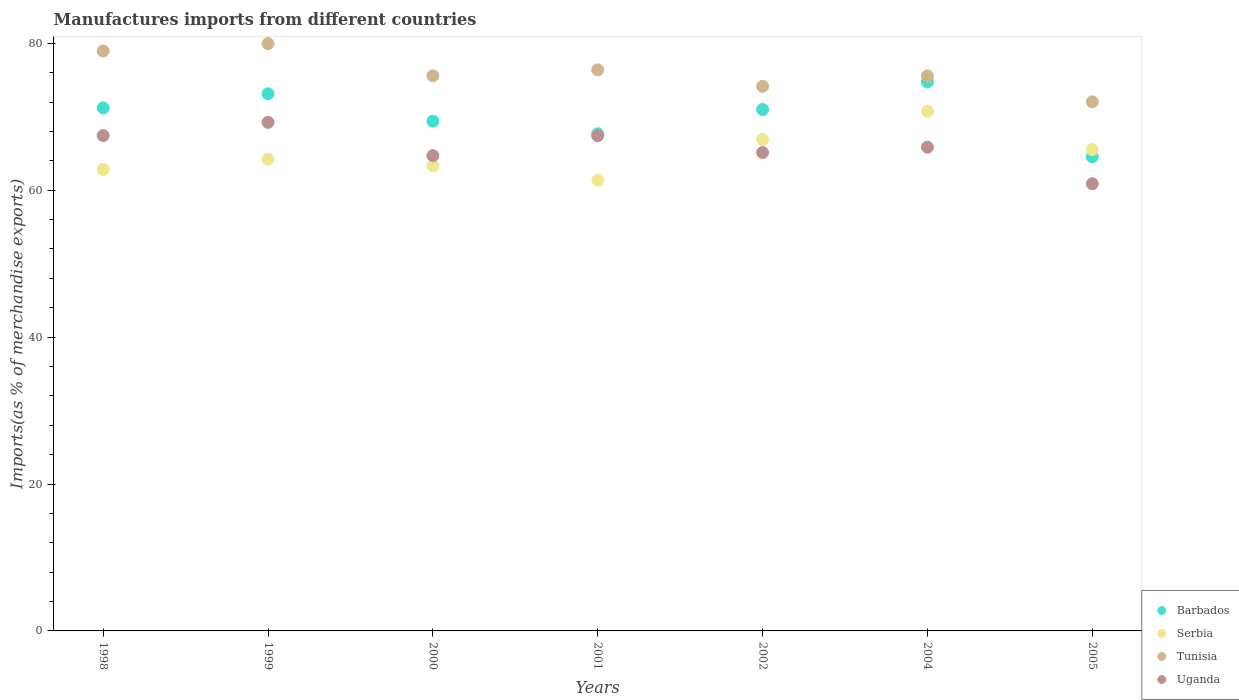Is the number of dotlines equal to the number of legend labels?
Offer a terse response. Yes. What is the percentage of imports to different countries in Serbia in 2005?
Offer a terse response. 65.52. Across all years, what is the maximum percentage of imports to different countries in Barbados?
Provide a short and direct response. 74.74. Across all years, what is the minimum percentage of imports to different countries in Uganda?
Your response must be concise. 60.88. What is the total percentage of imports to different countries in Uganda in the graph?
Provide a succinct answer. 460.66. What is the difference between the percentage of imports to different countries in Serbia in 1998 and that in 2002?
Make the answer very short. -4.08. What is the difference between the percentage of imports to different countries in Barbados in 1999 and the percentage of imports to different countries in Serbia in 2000?
Your answer should be compact. 9.79. What is the average percentage of imports to different countries in Tunisia per year?
Your answer should be very brief. 76.09. In the year 2002, what is the difference between the percentage of imports to different countries in Barbados and percentage of imports to different countries in Tunisia?
Make the answer very short. -3.16. In how many years, is the percentage of imports to different countries in Serbia greater than 24 %?
Provide a succinct answer. 7. What is the ratio of the percentage of imports to different countries in Tunisia in 1998 to that in 2002?
Make the answer very short. 1.06. Is the difference between the percentage of imports to different countries in Barbados in 2001 and 2004 greater than the difference between the percentage of imports to different countries in Tunisia in 2001 and 2004?
Offer a very short reply. No. What is the difference between the highest and the second highest percentage of imports to different countries in Barbados?
Make the answer very short. 1.61. What is the difference between the highest and the lowest percentage of imports to different countries in Uganda?
Your answer should be very brief. 8.36. Is the sum of the percentage of imports to different countries in Barbados in 1999 and 2002 greater than the maximum percentage of imports to different countries in Tunisia across all years?
Make the answer very short. Yes. Is it the case that in every year, the sum of the percentage of imports to different countries in Tunisia and percentage of imports to different countries in Serbia  is greater than the sum of percentage of imports to different countries in Barbados and percentage of imports to different countries in Uganda?
Your answer should be very brief. No. Does the percentage of imports to different countries in Barbados monotonically increase over the years?
Your response must be concise. No. How many dotlines are there?
Offer a very short reply. 4. What is the difference between two consecutive major ticks on the Y-axis?
Give a very brief answer. 20. Are the values on the major ticks of Y-axis written in scientific E-notation?
Your answer should be compact. No. How many legend labels are there?
Make the answer very short. 4. What is the title of the graph?
Your answer should be compact. Manufactures imports from different countries. What is the label or title of the Y-axis?
Your response must be concise. Imports(as % of merchandise exports). What is the Imports(as % of merchandise exports) of Barbados in 1998?
Make the answer very short. 71.2. What is the Imports(as % of merchandise exports) of Serbia in 1998?
Your response must be concise. 62.83. What is the Imports(as % of merchandise exports) in Tunisia in 1998?
Provide a succinct answer. 78.95. What is the Imports(as % of merchandise exports) of Uganda in 1998?
Provide a succinct answer. 67.44. What is the Imports(as % of merchandise exports) of Barbados in 1999?
Offer a terse response. 73.13. What is the Imports(as % of merchandise exports) of Serbia in 1999?
Keep it short and to the point. 64.21. What is the Imports(as % of merchandise exports) of Tunisia in 1999?
Offer a terse response. 79.96. What is the Imports(as % of merchandise exports) in Uganda in 1999?
Make the answer very short. 69.24. What is the Imports(as % of merchandise exports) of Barbados in 2000?
Offer a very short reply. 69.4. What is the Imports(as % of merchandise exports) in Serbia in 2000?
Make the answer very short. 63.34. What is the Imports(as % of merchandise exports) in Tunisia in 2000?
Your answer should be very brief. 75.58. What is the Imports(as % of merchandise exports) in Uganda in 2000?
Offer a terse response. 64.7. What is the Imports(as % of merchandise exports) of Barbados in 2001?
Your answer should be compact. 67.67. What is the Imports(as % of merchandise exports) in Serbia in 2001?
Ensure brevity in your answer.  61.36. What is the Imports(as % of merchandise exports) of Tunisia in 2001?
Make the answer very short. 76.38. What is the Imports(as % of merchandise exports) of Uganda in 2001?
Provide a short and direct response. 67.41. What is the Imports(as % of merchandise exports) of Barbados in 2002?
Give a very brief answer. 70.98. What is the Imports(as % of merchandise exports) of Serbia in 2002?
Make the answer very short. 66.91. What is the Imports(as % of merchandise exports) of Tunisia in 2002?
Your response must be concise. 74.14. What is the Imports(as % of merchandise exports) of Uganda in 2002?
Provide a succinct answer. 65.13. What is the Imports(as % of merchandise exports) of Barbados in 2004?
Make the answer very short. 74.74. What is the Imports(as % of merchandise exports) in Serbia in 2004?
Provide a succinct answer. 70.75. What is the Imports(as % of merchandise exports) in Tunisia in 2004?
Make the answer very short. 75.55. What is the Imports(as % of merchandise exports) in Uganda in 2004?
Offer a very short reply. 65.86. What is the Imports(as % of merchandise exports) of Barbados in 2005?
Your answer should be very brief. 64.55. What is the Imports(as % of merchandise exports) in Serbia in 2005?
Your answer should be very brief. 65.52. What is the Imports(as % of merchandise exports) in Tunisia in 2005?
Provide a short and direct response. 72.03. What is the Imports(as % of merchandise exports) in Uganda in 2005?
Provide a succinct answer. 60.88. Across all years, what is the maximum Imports(as % of merchandise exports) in Barbados?
Your answer should be very brief. 74.74. Across all years, what is the maximum Imports(as % of merchandise exports) of Serbia?
Provide a short and direct response. 70.75. Across all years, what is the maximum Imports(as % of merchandise exports) in Tunisia?
Give a very brief answer. 79.96. Across all years, what is the maximum Imports(as % of merchandise exports) of Uganda?
Provide a succinct answer. 69.24. Across all years, what is the minimum Imports(as % of merchandise exports) of Barbados?
Offer a very short reply. 64.55. Across all years, what is the minimum Imports(as % of merchandise exports) in Serbia?
Your answer should be very brief. 61.36. Across all years, what is the minimum Imports(as % of merchandise exports) of Tunisia?
Give a very brief answer. 72.03. Across all years, what is the minimum Imports(as % of merchandise exports) in Uganda?
Make the answer very short. 60.88. What is the total Imports(as % of merchandise exports) in Barbados in the graph?
Offer a very short reply. 491.68. What is the total Imports(as % of merchandise exports) in Serbia in the graph?
Offer a very short reply. 454.93. What is the total Imports(as % of merchandise exports) in Tunisia in the graph?
Your answer should be very brief. 532.61. What is the total Imports(as % of merchandise exports) of Uganda in the graph?
Your answer should be very brief. 460.66. What is the difference between the Imports(as % of merchandise exports) in Barbados in 1998 and that in 1999?
Make the answer very short. -1.92. What is the difference between the Imports(as % of merchandise exports) in Serbia in 1998 and that in 1999?
Your answer should be very brief. -1.38. What is the difference between the Imports(as % of merchandise exports) of Tunisia in 1998 and that in 1999?
Keep it short and to the point. -1.01. What is the difference between the Imports(as % of merchandise exports) in Uganda in 1998 and that in 1999?
Your response must be concise. -1.8. What is the difference between the Imports(as % of merchandise exports) in Barbados in 1998 and that in 2000?
Your answer should be compact. 1.81. What is the difference between the Imports(as % of merchandise exports) in Serbia in 1998 and that in 2000?
Keep it short and to the point. -0.5. What is the difference between the Imports(as % of merchandise exports) in Tunisia in 1998 and that in 2000?
Offer a very short reply. 3.38. What is the difference between the Imports(as % of merchandise exports) in Uganda in 1998 and that in 2000?
Provide a short and direct response. 2.73. What is the difference between the Imports(as % of merchandise exports) of Barbados in 1998 and that in 2001?
Provide a succinct answer. 3.53. What is the difference between the Imports(as % of merchandise exports) of Serbia in 1998 and that in 2001?
Offer a very short reply. 1.48. What is the difference between the Imports(as % of merchandise exports) of Tunisia in 1998 and that in 2001?
Your answer should be compact. 2.57. What is the difference between the Imports(as % of merchandise exports) in Uganda in 1998 and that in 2001?
Your answer should be compact. 0.03. What is the difference between the Imports(as % of merchandise exports) in Barbados in 1998 and that in 2002?
Keep it short and to the point. 0.22. What is the difference between the Imports(as % of merchandise exports) in Serbia in 1998 and that in 2002?
Make the answer very short. -4.08. What is the difference between the Imports(as % of merchandise exports) of Tunisia in 1998 and that in 2002?
Your answer should be compact. 4.81. What is the difference between the Imports(as % of merchandise exports) of Uganda in 1998 and that in 2002?
Provide a short and direct response. 2.31. What is the difference between the Imports(as % of merchandise exports) in Barbados in 1998 and that in 2004?
Offer a very short reply. -3.53. What is the difference between the Imports(as % of merchandise exports) of Serbia in 1998 and that in 2004?
Provide a succinct answer. -7.92. What is the difference between the Imports(as % of merchandise exports) of Tunisia in 1998 and that in 2004?
Provide a succinct answer. 3.4. What is the difference between the Imports(as % of merchandise exports) in Uganda in 1998 and that in 2004?
Your answer should be compact. 1.58. What is the difference between the Imports(as % of merchandise exports) of Barbados in 1998 and that in 2005?
Offer a terse response. 6.65. What is the difference between the Imports(as % of merchandise exports) of Serbia in 1998 and that in 2005?
Offer a terse response. -2.69. What is the difference between the Imports(as % of merchandise exports) of Tunisia in 1998 and that in 2005?
Ensure brevity in your answer.  6.92. What is the difference between the Imports(as % of merchandise exports) of Uganda in 1998 and that in 2005?
Make the answer very short. 6.56. What is the difference between the Imports(as % of merchandise exports) in Barbados in 1999 and that in 2000?
Your answer should be very brief. 3.73. What is the difference between the Imports(as % of merchandise exports) in Serbia in 1999 and that in 2000?
Provide a succinct answer. 0.88. What is the difference between the Imports(as % of merchandise exports) of Tunisia in 1999 and that in 2000?
Ensure brevity in your answer.  4.38. What is the difference between the Imports(as % of merchandise exports) in Uganda in 1999 and that in 2000?
Offer a terse response. 4.53. What is the difference between the Imports(as % of merchandise exports) of Barbados in 1999 and that in 2001?
Your response must be concise. 5.45. What is the difference between the Imports(as % of merchandise exports) in Serbia in 1999 and that in 2001?
Your answer should be very brief. 2.85. What is the difference between the Imports(as % of merchandise exports) of Tunisia in 1999 and that in 2001?
Your answer should be compact. 3.58. What is the difference between the Imports(as % of merchandise exports) in Uganda in 1999 and that in 2001?
Offer a very short reply. 1.83. What is the difference between the Imports(as % of merchandise exports) in Barbados in 1999 and that in 2002?
Make the answer very short. 2.14. What is the difference between the Imports(as % of merchandise exports) in Serbia in 1999 and that in 2002?
Ensure brevity in your answer.  -2.7. What is the difference between the Imports(as % of merchandise exports) in Tunisia in 1999 and that in 2002?
Keep it short and to the point. 5.82. What is the difference between the Imports(as % of merchandise exports) of Uganda in 1999 and that in 2002?
Provide a succinct answer. 4.11. What is the difference between the Imports(as % of merchandise exports) in Barbados in 1999 and that in 2004?
Your answer should be compact. -1.61. What is the difference between the Imports(as % of merchandise exports) of Serbia in 1999 and that in 2004?
Provide a short and direct response. -6.54. What is the difference between the Imports(as % of merchandise exports) of Tunisia in 1999 and that in 2004?
Give a very brief answer. 4.41. What is the difference between the Imports(as % of merchandise exports) in Uganda in 1999 and that in 2004?
Your response must be concise. 3.38. What is the difference between the Imports(as % of merchandise exports) in Barbados in 1999 and that in 2005?
Your answer should be compact. 8.58. What is the difference between the Imports(as % of merchandise exports) of Serbia in 1999 and that in 2005?
Provide a short and direct response. -1.31. What is the difference between the Imports(as % of merchandise exports) of Tunisia in 1999 and that in 2005?
Provide a short and direct response. 7.93. What is the difference between the Imports(as % of merchandise exports) in Uganda in 1999 and that in 2005?
Your answer should be compact. 8.36. What is the difference between the Imports(as % of merchandise exports) in Barbados in 2000 and that in 2001?
Keep it short and to the point. 1.72. What is the difference between the Imports(as % of merchandise exports) in Serbia in 2000 and that in 2001?
Provide a succinct answer. 1.98. What is the difference between the Imports(as % of merchandise exports) in Tunisia in 2000 and that in 2001?
Provide a succinct answer. -0.8. What is the difference between the Imports(as % of merchandise exports) in Uganda in 2000 and that in 2001?
Provide a succinct answer. -2.7. What is the difference between the Imports(as % of merchandise exports) of Barbados in 2000 and that in 2002?
Keep it short and to the point. -1.59. What is the difference between the Imports(as % of merchandise exports) of Serbia in 2000 and that in 2002?
Provide a short and direct response. -3.58. What is the difference between the Imports(as % of merchandise exports) in Tunisia in 2000 and that in 2002?
Your answer should be compact. 1.43. What is the difference between the Imports(as % of merchandise exports) of Uganda in 2000 and that in 2002?
Your answer should be very brief. -0.43. What is the difference between the Imports(as % of merchandise exports) in Barbados in 2000 and that in 2004?
Ensure brevity in your answer.  -5.34. What is the difference between the Imports(as % of merchandise exports) of Serbia in 2000 and that in 2004?
Keep it short and to the point. -7.42. What is the difference between the Imports(as % of merchandise exports) of Tunisia in 2000 and that in 2004?
Your answer should be compact. 0.03. What is the difference between the Imports(as % of merchandise exports) in Uganda in 2000 and that in 2004?
Your answer should be very brief. -1.15. What is the difference between the Imports(as % of merchandise exports) in Barbados in 2000 and that in 2005?
Provide a short and direct response. 4.85. What is the difference between the Imports(as % of merchandise exports) in Serbia in 2000 and that in 2005?
Provide a short and direct response. -2.19. What is the difference between the Imports(as % of merchandise exports) of Tunisia in 2000 and that in 2005?
Give a very brief answer. 3.54. What is the difference between the Imports(as % of merchandise exports) in Uganda in 2000 and that in 2005?
Provide a short and direct response. 3.82. What is the difference between the Imports(as % of merchandise exports) of Barbados in 2001 and that in 2002?
Keep it short and to the point. -3.31. What is the difference between the Imports(as % of merchandise exports) of Serbia in 2001 and that in 2002?
Ensure brevity in your answer.  -5.55. What is the difference between the Imports(as % of merchandise exports) of Tunisia in 2001 and that in 2002?
Make the answer very short. 2.24. What is the difference between the Imports(as % of merchandise exports) in Uganda in 2001 and that in 2002?
Ensure brevity in your answer.  2.28. What is the difference between the Imports(as % of merchandise exports) in Barbados in 2001 and that in 2004?
Your answer should be compact. -7.06. What is the difference between the Imports(as % of merchandise exports) of Serbia in 2001 and that in 2004?
Provide a short and direct response. -9.4. What is the difference between the Imports(as % of merchandise exports) in Tunisia in 2001 and that in 2004?
Your answer should be compact. 0.83. What is the difference between the Imports(as % of merchandise exports) of Uganda in 2001 and that in 2004?
Offer a terse response. 1.55. What is the difference between the Imports(as % of merchandise exports) in Barbados in 2001 and that in 2005?
Ensure brevity in your answer.  3.12. What is the difference between the Imports(as % of merchandise exports) of Serbia in 2001 and that in 2005?
Give a very brief answer. -4.16. What is the difference between the Imports(as % of merchandise exports) of Tunisia in 2001 and that in 2005?
Provide a short and direct response. 4.35. What is the difference between the Imports(as % of merchandise exports) in Uganda in 2001 and that in 2005?
Make the answer very short. 6.53. What is the difference between the Imports(as % of merchandise exports) in Barbados in 2002 and that in 2004?
Provide a short and direct response. -3.75. What is the difference between the Imports(as % of merchandise exports) of Serbia in 2002 and that in 2004?
Make the answer very short. -3.84. What is the difference between the Imports(as % of merchandise exports) in Tunisia in 2002 and that in 2004?
Keep it short and to the point. -1.41. What is the difference between the Imports(as % of merchandise exports) in Uganda in 2002 and that in 2004?
Offer a terse response. -0.73. What is the difference between the Imports(as % of merchandise exports) of Barbados in 2002 and that in 2005?
Make the answer very short. 6.43. What is the difference between the Imports(as % of merchandise exports) of Serbia in 2002 and that in 2005?
Your response must be concise. 1.39. What is the difference between the Imports(as % of merchandise exports) of Tunisia in 2002 and that in 2005?
Make the answer very short. 2.11. What is the difference between the Imports(as % of merchandise exports) in Uganda in 2002 and that in 2005?
Your answer should be very brief. 4.25. What is the difference between the Imports(as % of merchandise exports) in Barbados in 2004 and that in 2005?
Make the answer very short. 10.19. What is the difference between the Imports(as % of merchandise exports) in Serbia in 2004 and that in 2005?
Offer a terse response. 5.23. What is the difference between the Imports(as % of merchandise exports) in Tunisia in 2004 and that in 2005?
Ensure brevity in your answer.  3.52. What is the difference between the Imports(as % of merchandise exports) in Uganda in 2004 and that in 2005?
Your answer should be very brief. 4.98. What is the difference between the Imports(as % of merchandise exports) of Barbados in 1998 and the Imports(as % of merchandise exports) of Serbia in 1999?
Ensure brevity in your answer.  6.99. What is the difference between the Imports(as % of merchandise exports) of Barbados in 1998 and the Imports(as % of merchandise exports) of Tunisia in 1999?
Make the answer very short. -8.76. What is the difference between the Imports(as % of merchandise exports) in Barbados in 1998 and the Imports(as % of merchandise exports) in Uganda in 1999?
Your response must be concise. 1.97. What is the difference between the Imports(as % of merchandise exports) in Serbia in 1998 and the Imports(as % of merchandise exports) in Tunisia in 1999?
Keep it short and to the point. -17.13. What is the difference between the Imports(as % of merchandise exports) of Serbia in 1998 and the Imports(as % of merchandise exports) of Uganda in 1999?
Give a very brief answer. -6.4. What is the difference between the Imports(as % of merchandise exports) in Tunisia in 1998 and the Imports(as % of merchandise exports) in Uganda in 1999?
Your response must be concise. 9.72. What is the difference between the Imports(as % of merchandise exports) in Barbados in 1998 and the Imports(as % of merchandise exports) in Serbia in 2000?
Ensure brevity in your answer.  7.87. What is the difference between the Imports(as % of merchandise exports) in Barbados in 1998 and the Imports(as % of merchandise exports) in Tunisia in 2000?
Provide a short and direct response. -4.37. What is the difference between the Imports(as % of merchandise exports) in Barbados in 1998 and the Imports(as % of merchandise exports) in Uganda in 2000?
Ensure brevity in your answer.  6.5. What is the difference between the Imports(as % of merchandise exports) of Serbia in 1998 and the Imports(as % of merchandise exports) of Tunisia in 2000?
Keep it short and to the point. -12.74. What is the difference between the Imports(as % of merchandise exports) in Serbia in 1998 and the Imports(as % of merchandise exports) in Uganda in 2000?
Give a very brief answer. -1.87. What is the difference between the Imports(as % of merchandise exports) of Tunisia in 1998 and the Imports(as % of merchandise exports) of Uganda in 2000?
Offer a very short reply. 14.25. What is the difference between the Imports(as % of merchandise exports) of Barbados in 1998 and the Imports(as % of merchandise exports) of Serbia in 2001?
Make the answer very short. 9.85. What is the difference between the Imports(as % of merchandise exports) of Barbados in 1998 and the Imports(as % of merchandise exports) of Tunisia in 2001?
Offer a very short reply. -5.18. What is the difference between the Imports(as % of merchandise exports) of Barbados in 1998 and the Imports(as % of merchandise exports) of Uganda in 2001?
Give a very brief answer. 3.79. What is the difference between the Imports(as % of merchandise exports) of Serbia in 1998 and the Imports(as % of merchandise exports) of Tunisia in 2001?
Provide a succinct answer. -13.55. What is the difference between the Imports(as % of merchandise exports) in Serbia in 1998 and the Imports(as % of merchandise exports) in Uganda in 2001?
Make the answer very short. -4.58. What is the difference between the Imports(as % of merchandise exports) in Tunisia in 1998 and the Imports(as % of merchandise exports) in Uganda in 2001?
Your answer should be very brief. 11.54. What is the difference between the Imports(as % of merchandise exports) of Barbados in 1998 and the Imports(as % of merchandise exports) of Serbia in 2002?
Your response must be concise. 4.29. What is the difference between the Imports(as % of merchandise exports) of Barbados in 1998 and the Imports(as % of merchandise exports) of Tunisia in 2002?
Make the answer very short. -2.94. What is the difference between the Imports(as % of merchandise exports) of Barbados in 1998 and the Imports(as % of merchandise exports) of Uganda in 2002?
Keep it short and to the point. 6.07. What is the difference between the Imports(as % of merchandise exports) of Serbia in 1998 and the Imports(as % of merchandise exports) of Tunisia in 2002?
Offer a very short reply. -11.31. What is the difference between the Imports(as % of merchandise exports) in Serbia in 1998 and the Imports(as % of merchandise exports) in Uganda in 2002?
Your answer should be very brief. -2.3. What is the difference between the Imports(as % of merchandise exports) in Tunisia in 1998 and the Imports(as % of merchandise exports) in Uganda in 2002?
Offer a terse response. 13.82. What is the difference between the Imports(as % of merchandise exports) of Barbados in 1998 and the Imports(as % of merchandise exports) of Serbia in 2004?
Offer a very short reply. 0.45. What is the difference between the Imports(as % of merchandise exports) in Barbados in 1998 and the Imports(as % of merchandise exports) in Tunisia in 2004?
Your answer should be very brief. -4.35. What is the difference between the Imports(as % of merchandise exports) in Barbados in 1998 and the Imports(as % of merchandise exports) in Uganda in 2004?
Offer a very short reply. 5.35. What is the difference between the Imports(as % of merchandise exports) of Serbia in 1998 and the Imports(as % of merchandise exports) of Tunisia in 2004?
Your answer should be very brief. -12.72. What is the difference between the Imports(as % of merchandise exports) in Serbia in 1998 and the Imports(as % of merchandise exports) in Uganda in 2004?
Make the answer very short. -3.02. What is the difference between the Imports(as % of merchandise exports) in Tunisia in 1998 and the Imports(as % of merchandise exports) in Uganda in 2004?
Your response must be concise. 13.1. What is the difference between the Imports(as % of merchandise exports) in Barbados in 1998 and the Imports(as % of merchandise exports) in Serbia in 2005?
Provide a succinct answer. 5.68. What is the difference between the Imports(as % of merchandise exports) of Barbados in 1998 and the Imports(as % of merchandise exports) of Tunisia in 2005?
Give a very brief answer. -0.83. What is the difference between the Imports(as % of merchandise exports) in Barbados in 1998 and the Imports(as % of merchandise exports) in Uganda in 2005?
Your answer should be very brief. 10.32. What is the difference between the Imports(as % of merchandise exports) of Serbia in 1998 and the Imports(as % of merchandise exports) of Tunisia in 2005?
Ensure brevity in your answer.  -9.2. What is the difference between the Imports(as % of merchandise exports) of Serbia in 1998 and the Imports(as % of merchandise exports) of Uganda in 2005?
Ensure brevity in your answer.  1.95. What is the difference between the Imports(as % of merchandise exports) of Tunisia in 1998 and the Imports(as % of merchandise exports) of Uganda in 2005?
Your response must be concise. 18.07. What is the difference between the Imports(as % of merchandise exports) in Barbados in 1999 and the Imports(as % of merchandise exports) in Serbia in 2000?
Offer a very short reply. 9.79. What is the difference between the Imports(as % of merchandise exports) in Barbados in 1999 and the Imports(as % of merchandise exports) in Tunisia in 2000?
Make the answer very short. -2.45. What is the difference between the Imports(as % of merchandise exports) of Barbados in 1999 and the Imports(as % of merchandise exports) of Uganda in 2000?
Make the answer very short. 8.42. What is the difference between the Imports(as % of merchandise exports) in Serbia in 1999 and the Imports(as % of merchandise exports) in Tunisia in 2000?
Offer a terse response. -11.37. What is the difference between the Imports(as % of merchandise exports) of Serbia in 1999 and the Imports(as % of merchandise exports) of Uganda in 2000?
Your answer should be very brief. -0.49. What is the difference between the Imports(as % of merchandise exports) in Tunisia in 1999 and the Imports(as % of merchandise exports) in Uganda in 2000?
Keep it short and to the point. 15.26. What is the difference between the Imports(as % of merchandise exports) of Barbados in 1999 and the Imports(as % of merchandise exports) of Serbia in 2001?
Your answer should be compact. 11.77. What is the difference between the Imports(as % of merchandise exports) in Barbados in 1999 and the Imports(as % of merchandise exports) in Tunisia in 2001?
Your response must be concise. -3.25. What is the difference between the Imports(as % of merchandise exports) in Barbados in 1999 and the Imports(as % of merchandise exports) in Uganda in 2001?
Your answer should be compact. 5.72. What is the difference between the Imports(as % of merchandise exports) in Serbia in 1999 and the Imports(as % of merchandise exports) in Tunisia in 2001?
Offer a very short reply. -12.17. What is the difference between the Imports(as % of merchandise exports) in Serbia in 1999 and the Imports(as % of merchandise exports) in Uganda in 2001?
Ensure brevity in your answer.  -3.2. What is the difference between the Imports(as % of merchandise exports) in Tunisia in 1999 and the Imports(as % of merchandise exports) in Uganda in 2001?
Offer a terse response. 12.55. What is the difference between the Imports(as % of merchandise exports) in Barbados in 1999 and the Imports(as % of merchandise exports) in Serbia in 2002?
Ensure brevity in your answer.  6.21. What is the difference between the Imports(as % of merchandise exports) in Barbados in 1999 and the Imports(as % of merchandise exports) in Tunisia in 2002?
Your answer should be compact. -1.02. What is the difference between the Imports(as % of merchandise exports) of Barbados in 1999 and the Imports(as % of merchandise exports) of Uganda in 2002?
Provide a short and direct response. 8. What is the difference between the Imports(as % of merchandise exports) of Serbia in 1999 and the Imports(as % of merchandise exports) of Tunisia in 2002?
Keep it short and to the point. -9.93. What is the difference between the Imports(as % of merchandise exports) of Serbia in 1999 and the Imports(as % of merchandise exports) of Uganda in 2002?
Offer a terse response. -0.92. What is the difference between the Imports(as % of merchandise exports) of Tunisia in 1999 and the Imports(as % of merchandise exports) of Uganda in 2002?
Provide a succinct answer. 14.83. What is the difference between the Imports(as % of merchandise exports) in Barbados in 1999 and the Imports(as % of merchandise exports) in Serbia in 2004?
Your response must be concise. 2.37. What is the difference between the Imports(as % of merchandise exports) in Barbados in 1999 and the Imports(as % of merchandise exports) in Tunisia in 2004?
Give a very brief answer. -2.43. What is the difference between the Imports(as % of merchandise exports) in Barbados in 1999 and the Imports(as % of merchandise exports) in Uganda in 2004?
Ensure brevity in your answer.  7.27. What is the difference between the Imports(as % of merchandise exports) in Serbia in 1999 and the Imports(as % of merchandise exports) in Tunisia in 2004?
Your response must be concise. -11.34. What is the difference between the Imports(as % of merchandise exports) in Serbia in 1999 and the Imports(as % of merchandise exports) in Uganda in 2004?
Offer a very short reply. -1.65. What is the difference between the Imports(as % of merchandise exports) of Tunisia in 1999 and the Imports(as % of merchandise exports) of Uganda in 2004?
Keep it short and to the point. 14.1. What is the difference between the Imports(as % of merchandise exports) of Barbados in 1999 and the Imports(as % of merchandise exports) of Serbia in 2005?
Provide a short and direct response. 7.6. What is the difference between the Imports(as % of merchandise exports) of Barbados in 1999 and the Imports(as % of merchandise exports) of Tunisia in 2005?
Your response must be concise. 1.09. What is the difference between the Imports(as % of merchandise exports) in Barbados in 1999 and the Imports(as % of merchandise exports) in Uganda in 2005?
Your answer should be compact. 12.25. What is the difference between the Imports(as % of merchandise exports) in Serbia in 1999 and the Imports(as % of merchandise exports) in Tunisia in 2005?
Provide a short and direct response. -7.82. What is the difference between the Imports(as % of merchandise exports) of Serbia in 1999 and the Imports(as % of merchandise exports) of Uganda in 2005?
Provide a short and direct response. 3.33. What is the difference between the Imports(as % of merchandise exports) in Tunisia in 1999 and the Imports(as % of merchandise exports) in Uganda in 2005?
Offer a terse response. 19.08. What is the difference between the Imports(as % of merchandise exports) in Barbados in 2000 and the Imports(as % of merchandise exports) in Serbia in 2001?
Provide a succinct answer. 8.04. What is the difference between the Imports(as % of merchandise exports) of Barbados in 2000 and the Imports(as % of merchandise exports) of Tunisia in 2001?
Provide a short and direct response. -6.99. What is the difference between the Imports(as % of merchandise exports) in Barbados in 2000 and the Imports(as % of merchandise exports) in Uganda in 2001?
Your answer should be very brief. 1.99. What is the difference between the Imports(as % of merchandise exports) in Serbia in 2000 and the Imports(as % of merchandise exports) in Tunisia in 2001?
Your answer should be very brief. -13.05. What is the difference between the Imports(as % of merchandise exports) in Serbia in 2000 and the Imports(as % of merchandise exports) in Uganda in 2001?
Your answer should be compact. -4.07. What is the difference between the Imports(as % of merchandise exports) in Tunisia in 2000 and the Imports(as % of merchandise exports) in Uganda in 2001?
Your answer should be compact. 8.17. What is the difference between the Imports(as % of merchandise exports) of Barbados in 2000 and the Imports(as % of merchandise exports) of Serbia in 2002?
Your response must be concise. 2.48. What is the difference between the Imports(as % of merchandise exports) of Barbados in 2000 and the Imports(as % of merchandise exports) of Tunisia in 2002?
Your response must be concise. -4.75. What is the difference between the Imports(as % of merchandise exports) in Barbados in 2000 and the Imports(as % of merchandise exports) in Uganda in 2002?
Give a very brief answer. 4.27. What is the difference between the Imports(as % of merchandise exports) in Serbia in 2000 and the Imports(as % of merchandise exports) in Tunisia in 2002?
Your response must be concise. -10.81. What is the difference between the Imports(as % of merchandise exports) of Serbia in 2000 and the Imports(as % of merchandise exports) of Uganda in 2002?
Give a very brief answer. -1.79. What is the difference between the Imports(as % of merchandise exports) in Tunisia in 2000 and the Imports(as % of merchandise exports) in Uganda in 2002?
Your response must be concise. 10.45. What is the difference between the Imports(as % of merchandise exports) in Barbados in 2000 and the Imports(as % of merchandise exports) in Serbia in 2004?
Ensure brevity in your answer.  -1.36. What is the difference between the Imports(as % of merchandise exports) of Barbados in 2000 and the Imports(as % of merchandise exports) of Tunisia in 2004?
Your response must be concise. -6.16. What is the difference between the Imports(as % of merchandise exports) in Barbados in 2000 and the Imports(as % of merchandise exports) in Uganda in 2004?
Ensure brevity in your answer.  3.54. What is the difference between the Imports(as % of merchandise exports) of Serbia in 2000 and the Imports(as % of merchandise exports) of Tunisia in 2004?
Ensure brevity in your answer.  -12.22. What is the difference between the Imports(as % of merchandise exports) in Serbia in 2000 and the Imports(as % of merchandise exports) in Uganda in 2004?
Make the answer very short. -2.52. What is the difference between the Imports(as % of merchandise exports) in Tunisia in 2000 and the Imports(as % of merchandise exports) in Uganda in 2004?
Provide a succinct answer. 9.72. What is the difference between the Imports(as % of merchandise exports) in Barbados in 2000 and the Imports(as % of merchandise exports) in Serbia in 2005?
Keep it short and to the point. 3.87. What is the difference between the Imports(as % of merchandise exports) in Barbados in 2000 and the Imports(as % of merchandise exports) in Tunisia in 2005?
Offer a terse response. -2.64. What is the difference between the Imports(as % of merchandise exports) of Barbados in 2000 and the Imports(as % of merchandise exports) of Uganda in 2005?
Your answer should be compact. 8.52. What is the difference between the Imports(as % of merchandise exports) of Serbia in 2000 and the Imports(as % of merchandise exports) of Tunisia in 2005?
Your response must be concise. -8.7. What is the difference between the Imports(as % of merchandise exports) of Serbia in 2000 and the Imports(as % of merchandise exports) of Uganda in 2005?
Offer a very short reply. 2.46. What is the difference between the Imports(as % of merchandise exports) in Tunisia in 2000 and the Imports(as % of merchandise exports) in Uganda in 2005?
Provide a short and direct response. 14.7. What is the difference between the Imports(as % of merchandise exports) in Barbados in 2001 and the Imports(as % of merchandise exports) in Serbia in 2002?
Offer a terse response. 0.76. What is the difference between the Imports(as % of merchandise exports) of Barbados in 2001 and the Imports(as % of merchandise exports) of Tunisia in 2002?
Offer a very short reply. -6.47. What is the difference between the Imports(as % of merchandise exports) in Barbados in 2001 and the Imports(as % of merchandise exports) in Uganda in 2002?
Make the answer very short. 2.54. What is the difference between the Imports(as % of merchandise exports) of Serbia in 2001 and the Imports(as % of merchandise exports) of Tunisia in 2002?
Provide a succinct answer. -12.79. What is the difference between the Imports(as % of merchandise exports) of Serbia in 2001 and the Imports(as % of merchandise exports) of Uganda in 2002?
Keep it short and to the point. -3.77. What is the difference between the Imports(as % of merchandise exports) of Tunisia in 2001 and the Imports(as % of merchandise exports) of Uganda in 2002?
Provide a short and direct response. 11.25. What is the difference between the Imports(as % of merchandise exports) of Barbados in 2001 and the Imports(as % of merchandise exports) of Serbia in 2004?
Your answer should be very brief. -3.08. What is the difference between the Imports(as % of merchandise exports) in Barbados in 2001 and the Imports(as % of merchandise exports) in Tunisia in 2004?
Your response must be concise. -7.88. What is the difference between the Imports(as % of merchandise exports) of Barbados in 2001 and the Imports(as % of merchandise exports) of Uganda in 2004?
Provide a succinct answer. 1.82. What is the difference between the Imports(as % of merchandise exports) of Serbia in 2001 and the Imports(as % of merchandise exports) of Tunisia in 2004?
Keep it short and to the point. -14.19. What is the difference between the Imports(as % of merchandise exports) of Serbia in 2001 and the Imports(as % of merchandise exports) of Uganda in 2004?
Offer a terse response. -4.5. What is the difference between the Imports(as % of merchandise exports) of Tunisia in 2001 and the Imports(as % of merchandise exports) of Uganda in 2004?
Provide a succinct answer. 10.52. What is the difference between the Imports(as % of merchandise exports) in Barbados in 2001 and the Imports(as % of merchandise exports) in Serbia in 2005?
Ensure brevity in your answer.  2.15. What is the difference between the Imports(as % of merchandise exports) in Barbados in 2001 and the Imports(as % of merchandise exports) in Tunisia in 2005?
Provide a short and direct response. -4.36. What is the difference between the Imports(as % of merchandise exports) of Barbados in 2001 and the Imports(as % of merchandise exports) of Uganda in 2005?
Offer a terse response. 6.79. What is the difference between the Imports(as % of merchandise exports) of Serbia in 2001 and the Imports(as % of merchandise exports) of Tunisia in 2005?
Your answer should be compact. -10.68. What is the difference between the Imports(as % of merchandise exports) of Serbia in 2001 and the Imports(as % of merchandise exports) of Uganda in 2005?
Provide a short and direct response. 0.48. What is the difference between the Imports(as % of merchandise exports) in Tunisia in 2001 and the Imports(as % of merchandise exports) in Uganda in 2005?
Keep it short and to the point. 15.5. What is the difference between the Imports(as % of merchandise exports) in Barbados in 2002 and the Imports(as % of merchandise exports) in Serbia in 2004?
Offer a very short reply. 0.23. What is the difference between the Imports(as % of merchandise exports) of Barbados in 2002 and the Imports(as % of merchandise exports) of Tunisia in 2004?
Offer a very short reply. -4.57. What is the difference between the Imports(as % of merchandise exports) of Barbados in 2002 and the Imports(as % of merchandise exports) of Uganda in 2004?
Your answer should be very brief. 5.13. What is the difference between the Imports(as % of merchandise exports) in Serbia in 2002 and the Imports(as % of merchandise exports) in Tunisia in 2004?
Ensure brevity in your answer.  -8.64. What is the difference between the Imports(as % of merchandise exports) of Serbia in 2002 and the Imports(as % of merchandise exports) of Uganda in 2004?
Keep it short and to the point. 1.05. What is the difference between the Imports(as % of merchandise exports) of Tunisia in 2002 and the Imports(as % of merchandise exports) of Uganda in 2004?
Give a very brief answer. 8.29. What is the difference between the Imports(as % of merchandise exports) in Barbados in 2002 and the Imports(as % of merchandise exports) in Serbia in 2005?
Provide a short and direct response. 5.46. What is the difference between the Imports(as % of merchandise exports) in Barbados in 2002 and the Imports(as % of merchandise exports) in Tunisia in 2005?
Provide a succinct answer. -1.05. What is the difference between the Imports(as % of merchandise exports) in Barbados in 2002 and the Imports(as % of merchandise exports) in Uganda in 2005?
Give a very brief answer. 10.1. What is the difference between the Imports(as % of merchandise exports) of Serbia in 2002 and the Imports(as % of merchandise exports) of Tunisia in 2005?
Offer a very short reply. -5.12. What is the difference between the Imports(as % of merchandise exports) of Serbia in 2002 and the Imports(as % of merchandise exports) of Uganda in 2005?
Offer a very short reply. 6.03. What is the difference between the Imports(as % of merchandise exports) in Tunisia in 2002 and the Imports(as % of merchandise exports) in Uganda in 2005?
Your answer should be very brief. 13.26. What is the difference between the Imports(as % of merchandise exports) of Barbados in 2004 and the Imports(as % of merchandise exports) of Serbia in 2005?
Keep it short and to the point. 9.22. What is the difference between the Imports(as % of merchandise exports) of Barbados in 2004 and the Imports(as % of merchandise exports) of Tunisia in 2005?
Ensure brevity in your answer.  2.7. What is the difference between the Imports(as % of merchandise exports) in Barbados in 2004 and the Imports(as % of merchandise exports) in Uganda in 2005?
Offer a very short reply. 13.86. What is the difference between the Imports(as % of merchandise exports) of Serbia in 2004 and the Imports(as % of merchandise exports) of Tunisia in 2005?
Ensure brevity in your answer.  -1.28. What is the difference between the Imports(as % of merchandise exports) of Serbia in 2004 and the Imports(as % of merchandise exports) of Uganda in 2005?
Make the answer very short. 9.87. What is the difference between the Imports(as % of merchandise exports) of Tunisia in 2004 and the Imports(as % of merchandise exports) of Uganda in 2005?
Your answer should be very brief. 14.67. What is the average Imports(as % of merchandise exports) of Barbados per year?
Provide a succinct answer. 70.24. What is the average Imports(as % of merchandise exports) of Serbia per year?
Your answer should be very brief. 64.99. What is the average Imports(as % of merchandise exports) in Tunisia per year?
Keep it short and to the point. 76.09. What is the average Imports(as % of merchandise exports) of Uganda per year?
Your answer should be compact. 65.81. In the year 1998, what is the difference between the Imports(as % of merchandise exports) in Barbados and Imports(as % of merchandise exports) in Serbia?
Give a very brief answer. 8.37. In the year 1998, what is the difference between the Imports(as % of merchandise exports) in Barbados and Imports(as % of merchandise exports) in Tunisia?
Your response must be concise. -7.75. In the year 1998, what is the difference between the Imports(as % of merchandise exports) of Barbados and Imports(as % of merchandise exports) of Uganda?
Ensure brevity in your answer.  3.77. In the year 1998, what is the difference between the Imports(as % of merchandise exports) of Serbia and Imports(as % of merchandise exports) of Tunisia?
Your answer should be very brief. -16.12. In the year 1998, what is the difference between the Imports(as % of merchandise exports) in Serbia and Imports(as % of merchandise exports) in Uganda?
Offer a very short reply. -4.6. In the year 1998, what is the difference between the Imports(as % of merchandise exports) of Tunisia and Imports(as % of merchandise exports) of Uganda?
Provide a short and direct response. 11.52. In the year 1999, what is the difference between the Imports(as % of merchandise exports) of Barbados and Imports(as % of merchandise exports) of Serbia?
Give a very brief answer. 8.91. In the year 1999, what is the difference between the Imports(as % of merchandise exports) of Barbados and Imports(as % of merchandise exports) of Tunisia?
Give a very brief answer. -6.83. In the year 1999, what is the difference between the Imports(as % of merchandise exports) in Barbados and Imports(as % of merchandise exports) in Uganda?
Your answer should be compact. 3.89. In the year 1999, what is the difference between the Imports(as % of merchandise exports) of Serbia and Imports(as % of merchandise exports) of Tunisia?
Offer a very short reply. -15.75. In the year 1999, what is the difference between the Imports(as % of merchandise exports) in Serbia and Imports(as % of merchandise exports) in Uganda?
Provide a succinct answer. -5.03. In the year 1999, what is the difference between the Imports(as % of merchandise exports) of Tunisia and Imports(as % of merchandise exports) of Uganda?
Give a very brief answer. 10.72. In the year 2000, what is the difference between the Imports(as % of merchandise exports) of Barbados and Imports(as % of merchandise exports) of Serbia?
Offer a very short reply. 6.06. In the year 2000, what is the difference between the Imports(as % of merchandise exports) of Barbados and Imports(as % of merchandise exports) of Tunisia?
Your answer should be compact. -6.18. In the year 2000, what is the difference between the Imports(as % of merchandise exports) of Barbados and Imports(as % of merchandise exports) of Uganda?
Make the answer very short. 4.69. In the year 2000, what is the difference between the Imports(as % of merchandise exports) in Serbia and Imports(as % of merchandise exports) in Tunisia?
Offer a very short reply. -12.24. In the year 2000, what is the difference between the Imports(as % of merchandise exports) of Serbia and Imports(as % of merchandise exports) of Uganda?
Give a very brief answer. -1.37. In the year 2000, what is the difference between the Imports(as % of merchandise exports) of Tunisia and Imports(as % of merchandise exports) of Uganda?
Your response must be concise. 10.87. In the year 2001, what is the difference between the Imports(as % of merchandise exports) in Barbados and Imports(as % of merchandise exports) in Serbia?
Keep it short and to the point. 6.32. In the year 2001, what is the difference between the Imports(as % of merchandise exports) in Barbados and Imports(as % of merchandise exports) in Tunisia?
Provide a short and direct response. -8.71. In the year 2001, what is the difference between the Imports(as % of merchandise exports) of Barbados and Imports(as % of merchandise exports) of Uganda?
Offer a very short reply. 0.26. In the year 2001, what is the difference between the Imports(as % of merchandise exports) of Serbia and Imports(as % of merchandise exports) of Tunisia?
Offer a terse response. -15.02. In the year 2001, what is the difference between the Imports(as % of merchandise exports) of Serbia and Imports(as % of merchandise exports) of Uganda?
Give a very brief answer. -6.05. In the year 2001, what is the difference between the Imports(as % of merchandise exports) in Tunisia and Imports(as % of merchandise exports) in Uganda?
Make the answer very short. 8.97. In the year 2002, what is the difference between the Imports(as % of merchandise exports) of Barbados and Imports(as % of merchandise exports) of Serbia?
Offer a terse response. 4.07. In the year 2002, what is the difference between the Imports(as % of merchandise exports) of Barbados and Imports(as % of merchandise exports) of Tunisia?
Make the answer very short. -3.16. In the year 2002, what is the difference between the Imports(as % of merchandise exports) in Barbados and Imports(as % of merchandise exports) in Uganda?
Keep it short and to the point. 5.85. In the year 2002, what is the difference between the Imports(as % of merchandise exports) of Serbia and Imports(as % of merchandise exports) of Tunisia?
Give a very brief answer. -7.23. In the year 2002, what is the difference between the Imports(as % of merchandise exports) in Serbia and Imports(as % of merchandise exports) in Uganda?
Keep it short and to the point. 1.78. In the year 2002, what is the difference between the Imports(as % of merchandise exports) in Tunisia and Imports(as % of merchandise exports) in Uganda?
Give a very brief answer. 9.01. In the year 2004, what is the difference between the Imports(as % of merchandise exports) in Barbados and Imports(as % of merchandise exports) in Serbia?
Provide a short and direct response. 3.98. In the year 2004, what is the difference between the Imports(as % of merchandise exports) in Barbados and Imports(as % of merchandise exports) in Tunisia?
Provide a succinct answer. -0.81. In the year 2004, what is the difference between the Imports(as % of merchandise exports) of Barbados and Imports(as % of merchandise exports) of Uganda?
Your answer should be compact. 8.88. In the year 2004, what is the difference between the Imports(as % of merchandise exports) of Serbia and Imports(as % of merchandise exports) of Tunisia?
Provide a short and direct response. -4.8. In the year 2004, what is the difference between the Imports(as % of merchandise exports) in Serbia and Imports(as % of merchandise exports) in Uganda?
Ensure brevity in your answer.  4.9. In the year 2004, what is the difference between the Imports(as % of merchandise exports) in Tunisia and Imports(as % of merchandise exports) in Uganda?
Your answer should be very brief. 9.69. In the year 2005, what is the difference between the Imports(as % of merchandise exports) of Barbados and Imports(as % of merchandise exports) of Serbia?
Make the answer very short. -0.97. In the year 2005, what is the difference between the Imports(as % of merchandise exports) in Barbados and Imports(as % of merchandise exports) in Tunisia?
Provide a succinct answer. -7.48. In the year 2005, what is the difference between the Imports(as % of merchandise exports) of Barbados and Imports(as % of merchandise exports) of Uganda?
Make the answer very short. 3.67. In the year 2005, what is the difference between the Imports(as % of merchandise exports) of Serbia and Imports(as % of merchandise exports) of Tunisia?
Give a very brief answer. -6.51. In the year 2005, what is the difference between the Imports(as % of merchandise exports) in Serbia and Imports(as % of merchandise exports) in Uganda?
Provide a short and direct response. 4.64. In the year 2005, what is the difference between the Imports(as % of merchandise exports) of Tunisia and Imports(as % of merchandise exports) of Uganda?
Ensure brevity in your answer.  11.15. What is the ratio of the Imports(as % of merchandise exports) of Barbados in 1998 to that in 1999?
Your answer should be very brief. 0.97. What is the ratio of the Imports(as % of merchandise exports) of Serbia in 1998 to that in 1999?
Offer a terse response. 0.98. What is the ratio of the Imports(as % of merchandise exports) of Tunisia in 1998 to that in 1999?
Your answer should be compact. 0.99. What is the ratio of the Imports(as % of merchandise exports) in Uganda in 1998 to that in 1999?
Give a very brief answer. 0.97. What is the ratio of the Imports(as % of merchandise exports) of Serbia in 1998 to that in 2000?
Keep it short and to the point. 0.99. What is the ratio of the Imports(as % of merchandise exports) in Tunisia in 1998 to that in 2000?
Your answer should be very brief. 1.04. What is the ratio of the Imports(as % of merchandise exports) in Uganda in 1998 to that in 2000?
Keep it short and to the point. 1.04. What is the ratio of the Imports(as % of merchandise exports) in Barbados in 1998 to that in 2001?
Provide a short and direct response. 1.05. What is the ratio of the Imports(as % of merchandise exports) in Serbia in 1998 to that in 2001?
Offer a very short reply. 1.02. What is the ratio of the Imports(as % of merchandise exports) in Tunisia in 1998 to that in 2001?
Your answer should be very brief. 1.03. What is the ratio of the Imports(as % of merchandise exports) of Uganda in 1998 to that in 2001?
Offer a terse response. 1. What is the ratio of the Imports(as % of merchandise exports) of Serbia in 1998 to that in 2002?
Give a very brief answer. 0.94. What is the ratio of the Imports(as % of merchandise exports) in Tunisia in 1998 to that in 2002?
Your answer should be compact. 1.06. What is the ratio of the Imports(as % of merchandise exports) of Uganda in 1998 to that in 2002?
Provide a short and direct response. 1.04. What is the ratio of the Imports(as % of merchandise exports) of Barbados in 1998 to that in 2004?
Keep it short and to the point. 0.95. What is the ratio of the Imports(as % of merchandise exports) of Serbia in 1998 to that in 2004?
Make the answer very short. 0.89. What is the ratio of the Imports(as % of merchandise exports) in Tunisia in 1998 to that in 2004?
Offer a very short reply. 1.04. What is the ratio of the Imports(as % of merchandise exports) of Uganda in 1998 to that in 2004?
Offer a very short reply. 1.02. What is the ratio of the Imports(as % of merchandise exports) of Barbados in 1998 to that in 2005?
Your response must be concise. 1.1. What is the ratio of the Imports(as % of merchandise exports) of Serbia in 1998 to that in 2005?
Your answer should be very brief. 0.96. What is the ratio of the Imports(as % of merchandise exports) of Tunisia in 1998 to that in 2005?
Offer a very short reply. 1.1. What is the ratio of the Imports(as % of merchandise exports) of Uganda in 1998 to that in 2005?
Give a very brief answer. 1.11. What is the ratio of the Imports(as % of merchandise exports) of Barbados in 1999 to that in 2000?
Your response must be concise. 1.05. What is the ratio of the Imports(as % of merchandise exports) of Serbia in 1999 to that in 2000?
Make the answer very short. 1.01. What is the ratio of the Imports(as % of merchandise exports) in Tunisia in 1999 to that in 2000?
Your answer should be compact. 1.06. What is the ratio of the Imports(as % of merchandise exports) in Uganda in 1999 to that in 2000?
Offer a very short reply. 1.07. What is the ratio of the Imports(as % of merchandise exports) of Barbados in 1999 to that in 2001?
Give a very brief answer. 1.08. What is the ratio of the Imports(as % of merchandise exports) in Serbia in 1999 to that in 2001?
Your response must be concise. 1.05. What is the ratio of the Imports(as % of merchandise exports) of Tunisia in 1999 to that in 2001?
Ensure brevity in your answer.  1.05. What is the ratio of the Imports(as % of merchandise exports) in Uganda in 1999 to that in 2001?
Your answer should be compact. 1.03. What is the ratio of the Imports(as % of merchandise exports) in Barbados in 1999 to that in 2002?
Offer a very short reply. 1.03. What is the ratio of the Imports(as % of merchandise exports) of Serbia in 1999 to that in 2002?
Make the answer very short. 0.96. What is the ratio of the Imports(as % of merchandise exports) of Tunisia in 1999 to that in 2002?
Offer a very short reply. 1.08. What is the ratio of the Imports(as % of merchandise exports) of Uganda in 1999 to that in 2002?
Your response must be concise. 1.06. What is the ratio of the Imports(as % of merchandise exports) in Barbados in 1999 to that in 2004?
Your answer should be compact. 0.98. What is the ratio of the Imports(as % of merchandise exports) in Serbia in 1999 to that in 2004?
Your answer should be compact. 0.91. What is the ratio of the Imports(as % of merchandise exports) of Tunisia in 1999 to that in 2004?
Your answer should be very brief. 1.06. What is the ratio of the Imports(as % of merchandise exports) of Uganda in 1999 to that in 2004?
Your response must be concise. 1.05. What is the ratio of the Imports(as % of merchandise exports) in Barbados in 1999 to that in 2005?
Ensure brevity in your answer.  1.13. What is the ratio of the Imports(as % of merchandise exports) of Serbia in 1999 to that in 2005?
Your answer should be compact. 0.98. What is the ratio of the Imports(as % of merchandise exports) of Tunisia in 1999 to that in 2005?
Offer a terse response. 1.11. What is the ratio of the Imports(as % of merchandise exports) in Uganda in 1999 to that in 2005?
Your answer should be compact. 1.14. What is the ratio of the Imports(as % of merchandise exports) in Barbados in 2000 to that in 2001?
Offer a terse response. 1.03. What is the ratio of the Imports(as % of merchandise exports) in Serbia in 2000 to that in 2001?
Offer a terse response. 1.03. What is the ratio of the Imports(as % of merchandise exports) of Tunisia in 2000 to that in 2001?
Give a very brief answer. 0.99. What is the ratio of the Imports(as % of merchandise exports) of Uganda in 2000 to that in 2001?
Offer a very short reply. 0.96. What is the ratio of the Imports(as % of merchandise exports) in Barbados in 2000 to that in 2002?
Your answer should be very brief. 0.98. What is the ratio of the Imports(as % of merchandise exports) in Serbia in 2000 to that in 2002?
Provide a short and direct response. 0.95. What is the ratio of the Imports(as % of merchandise exports) of Tunisia in 2000 to that in 2002?
Keep it short and to the point. 1.02. What is the ratio of the Imports(as % of merchandise exports) of Barbados in 2000 to that in 2004?
Your answer should be compact. 0.93. What is the ratio of the Imports(as % of merchandise exports) of Serbia in 2000 to that in 2004?
Offer a very short reply. 0.9. What is the ratio of the Imports(as % of merchandise exports) in Tunisia in 2000 to that in 2004?
Keep it short and to the point. 1. What is the ratio of the Imports(as % of merchandise exports) in Uganda in 2000 to that in 2004?
Make the answer very short. 0.98. What is the ratio of the Imports(as % of merchandise exports) of Barbados in 2000 to that in 2005?
Make the answer very short. 1.08. What is the ratio of the Imports(as % of merchandise exports) in Serbia in 2000 to that in 2005?
Provide a succinct answer. 0.97. What is the ratio of the Imports(as % of merchandise exports) in Tunisia in 2000 to that in 2005?
Offer a terse response. 1.05. What is the ratio of the Imports(as % of merchandise exports) in Uganda in 2000 to that in 2005?
Offer a terse response. 1.06. What is the ratio of the Imports(as % of merchandise exports) of Barbados in 2001 to that in 2002?
Give a very brief answer. 0.95. What is the ratio of the Imports(as % of merchandise exports) of Serbia in 2001 to that in 2002?
Give a very brief answer. 0.92. What is the ratio of the Imports(as % of merchandise exports) in Tunisia in 2001 to that in 2002?
Ensure brevity in your answer.  1.03. What is the ratio of the Imports(as % of merchandise exports) in Uganda in 2001 to that in 2002?
Offer a terse response. 1.03. What is the ratio of the Imports(as % of merchandise exports) in Barbados in 2001 to that in 2004?
Ensure brevity in your answer.  0.91. What is the ratio of the Imports(as % of merchandise exports) of Serbia in 2001 to that in 2004?
Provide a short and direct response. 0.87. What is the ratio of the Imports(as % of merchandise exports) in Uganda in 2001 to that in 2004?
Offer a very short reply. 1.02. What is the ratio of the Imports(as % of merchandise exports) of Barbados in 2001 to that in 2005?
Your response must be concise. 1.05. What is the ratio of the Imports(as % of merchandise exports) of Serbia in 2001 to that in 2005?
Make the answer very short. 0.94. What is the ratio of the Imports(as % of merchandise exports) in Tunisia in 2001 to that in 2005?
Offer a terse response. 1.06. What is the ratio of the Imports(as % of merchandise exports) in Uganda in 2001 to that in 2005?
Offer a very short reply. 1.11. What is the ratio of the Imports(as % of merchandise exports) of Barbados in 2002 to that in 2004?
Offer a very short reply. 0.95. What is the ratio of the Imports(as % of merchandise exports) in Serbia in 2002 to that in 2004?
Keep it short and to the point. 0.95. What is the ratio of the Imports(as % of merchandise exports) in Tunisia in 2002 to that in 2004?
Your answer should be very brief. 0.98. What is the ratio of the Imports(as % of merchandise exports) of Uganda in 2002 to that in 2004?
Provide a short and direct response. 0.99. What is the ratio of the Imports(as % of merchandise exports) in Barbados in 2002 to that in 2005?
Provide a short and direct response. 1.1. What is the ratio of the Imports(as % of merchandise exports) in Serbia in 2002 to that in 2005?
Give a very brief answer. 1.02. What is the ratio of the Imports(as % of merchandise exports) of Tunisia in 2002 to that in 2005?
Ensure brevity in your answer.  1.03. What is the ratio of the Imports(as % of merchandise exports) of Uganda in 2002 to that in 2005?
Your answer should be very brief. 1.07. What is the ratio of the Imports(as % of merchandise exports) of Barbados in 2004 to that in 2005?
Keep it short and to the point. 1.16. What is the ratio of the Imports(as % of merchandise exports) of Serbia in 2004 to that in 2005?
Provide a succinct answer. 1.08. What is the ratio of the Imports(as % of merchandise exports) in Tunisia in 2004 to that in 2005?
Provide a succinct answer. 1.05. What is the ratio of the Imports(as % of merchandise exports) in Uganda in 2004 to that in 2005?
Ensure brevity in your answer.  1.08. What is the difference between the highest and the second highest Imports(as % of merchandise exports) of Barbados?
Offer a very short reply. 1.61. What is the difference between the highest and the second highest Imports(as % of merchandise exports) of Serbia?
Provide a succinct answer. 3.84. What is the difference between the highest and the second highest Imports(as % of merchandise exports) in Tunisia?
Give a very brief answer. 1.01. What is the difference between the highest and the second highest Imports(as % of merchandise exports) of Uganda?
Ensure brevity in your answer.  1.8. What is the difference between the highest and the lowest Imports(as % of merchandise exports) in Barbados?
Offer a very short reply. 10.19. What is the difference between the highest and the lowest Imports(as % of merchandise exports) in Serbia?
Your answer should be very brief. 9.4. What is the difference between the highest and the lowest Imports(as % of merchandise exports) in Tunisia?
Give a very brief answer. 7.93. What is the difference between the highest and the lowest Imports(as % of merchandise exports) of Uganda?
Your answer should be compact. 8.36. 